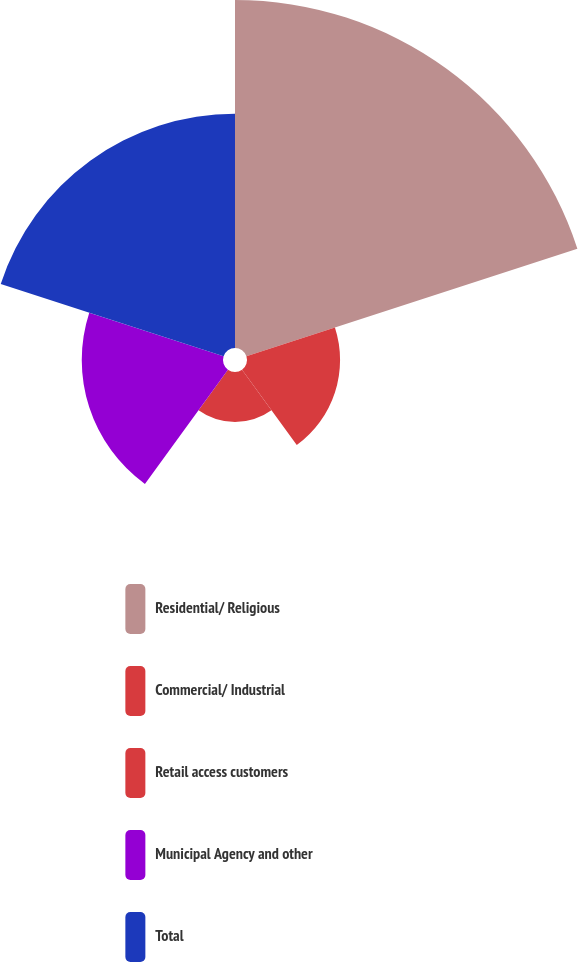<chart> <loc_0><loc_0><loc_500><loc_500><pie_chart><fcel>Residential/ Religious<fcel>Commercial/ Industrial<fcel>Retail access customers<fcel>Municipal Agency and other<fcel>Total<nl><fcel>40.16%<fcel>10.74%<fcel>5.77%<fcel>16.3%<fcel>27.04%<nl></chart> 